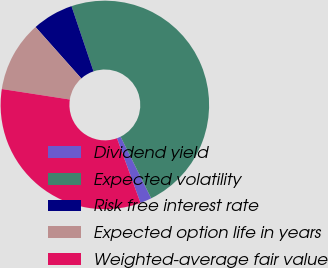<chart> <loc_0><loc_0><loc_500><loc_500><pie_chart><fcel>Dividend yield<fcel>Expected volatility<fcel>Risk free interest rate<fcel>Expected option life in years<fcel>Weighted-average fair value<nl><fcel>1.78%<fcel>47.85%<fcel>6.39%<fcel>10.99%<fcel>32.99%<nl></chart> 